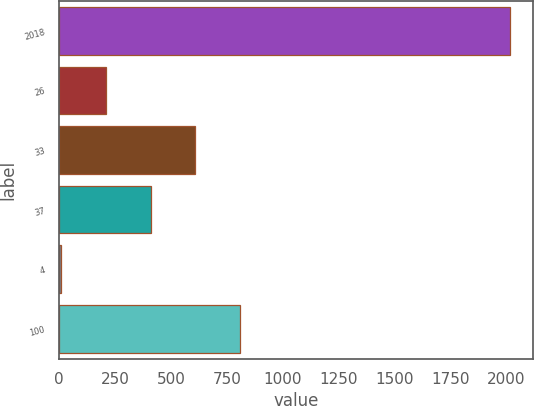Convert chart. <chart><loc_0><loc_0><loc_500><loc_500><bar_chart><fcel>2018<fcel>26<fcel>33<fcel>37<fcel>4<fcel>100<nl><fcel>2016<fcel>207<fcel>609<fcel>408<fcel>6<fcel>810<nl></chart> 